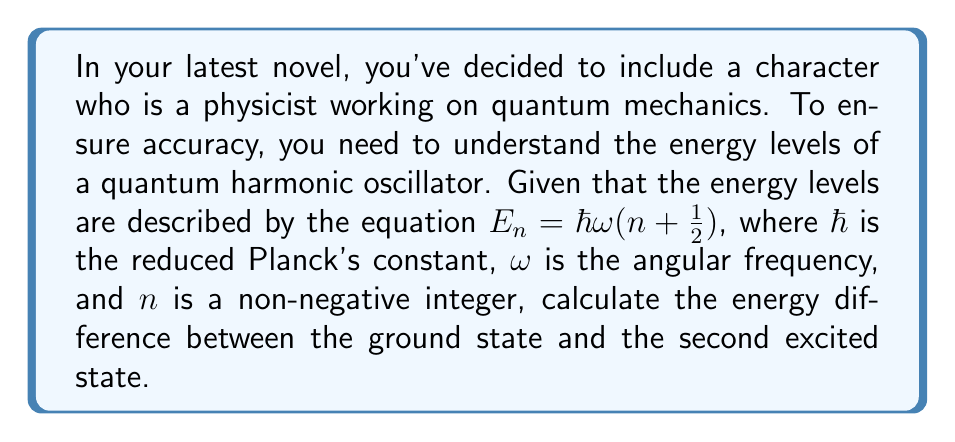Could you help me with this problem? To solve this problem, we'll follow these steps:

1) First, let's identify the states we're comparing:
   - Ground state: $n = 0$
   - Second excited state: $n = 2$

2) Now, let's calculate the energy of each state using the given equation:

   For the ground state $(n = 0)$:
   $$E_0 = \hbar \omega (0 + \frac{1}{2}) = \frac{1}{2}\hbar \omega$$

   For the second excited state $(n = 2)$:
   $$E_2 = \hbar \omega (2 + \frac{1}{2}) = \frac{5}{2}\hbar \omega$$

3) To find the energy difference, we subtract the ground state energy from the second excited state energy:

   $$\Delta E = E_2 - E_0 = \frac{5}{2}\hbar \omega - \frac{1}{2}\hbar \omega = 2\hbar \omega$$

Therefore, the energy difference between the ground state and the second excited state is $2\hbar \omega$.
Answer: $2\hbar \omega$ 